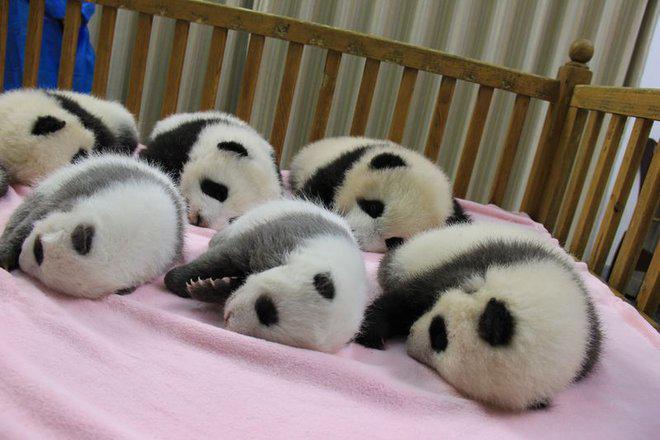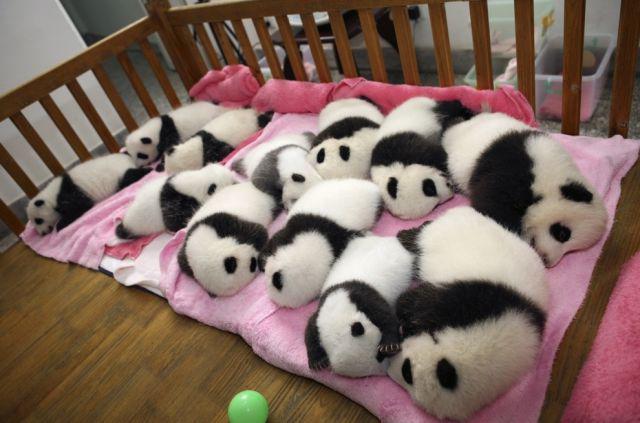The first image is the image on the left, the second image is the image on the right. Examine the images to the left and right. Is the description "An image shows rows of pandas sleeping on a pink blanket surrounded by rails, and a green ball is next to the blanket." accurate? Answer yes or no. Yes. The first image is the image on the left, the second image is the image on the right. Examine the images to the left and right. Is the description "The left image contains baby pandas sleeping on a pink blanket." accurate? Answer yes or no. Yes. 